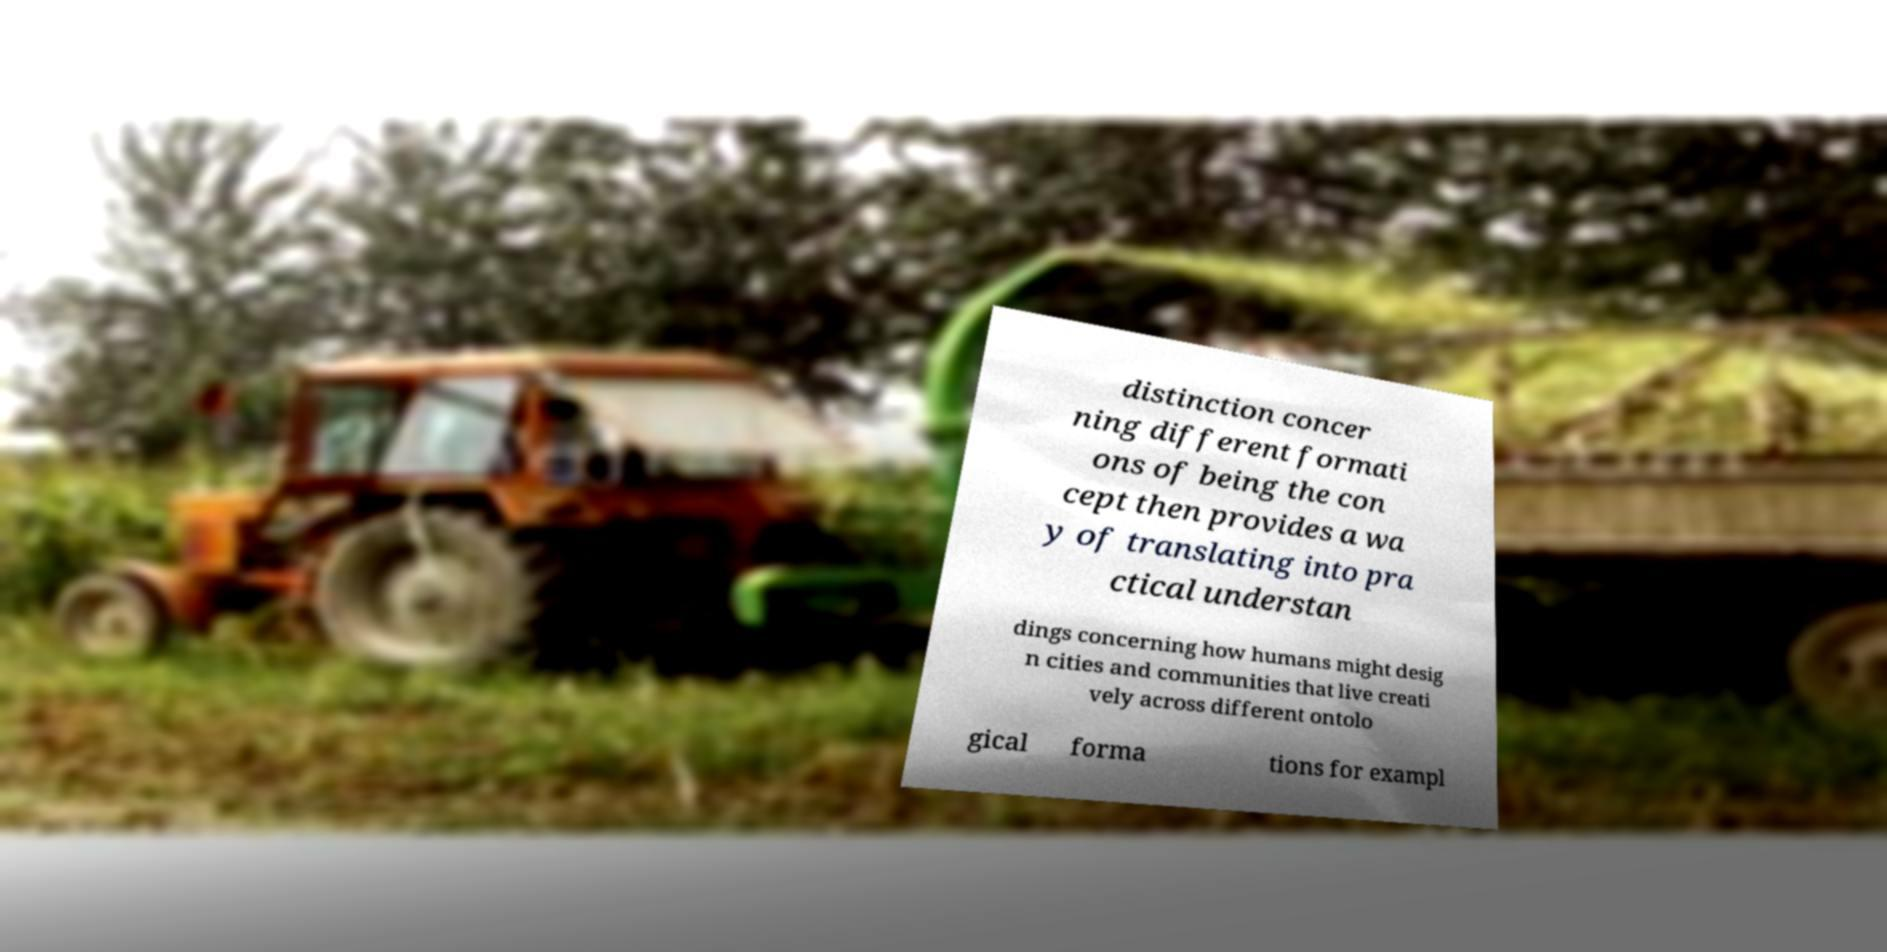Please read and relay the text visible in this image. What does it say? distinction concer ning different formati ons of being the con cept then provides a wa y of translating into pra ctical understan dings concerning how humans might desig n cities and communities that live creati vely across different ontolo gical forma tions for exampl 